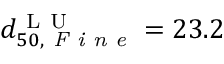<formula> <loc_0><loc_0><loc_500><loc_500>d _ { 5 0 , F i n e } ^ { L U } = 2 3 . 2</formula> 